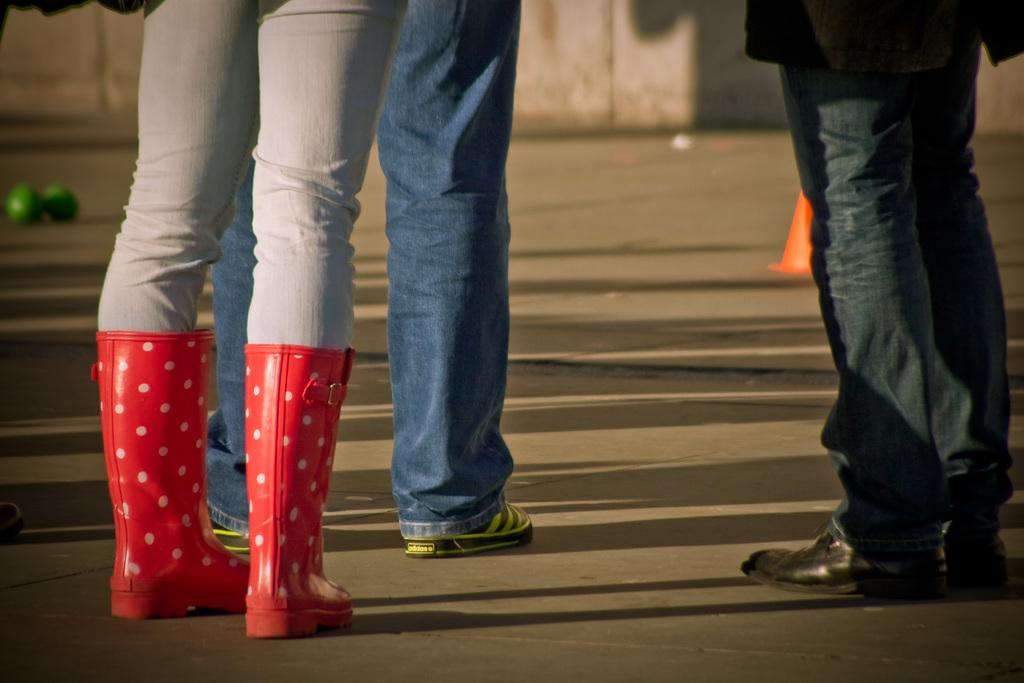How many people are represented by the legs visible in the image? There are legs of three people visible in the image. Where are the legs located? The legs are on a road. What can be seen in the background of the image? There is a wall and some unspecified objects in the background of the image. What type of birthday celebration is taking place in the image? There is no indication of a birthday celebration in the image; it only shows the legs of three people on a road. 